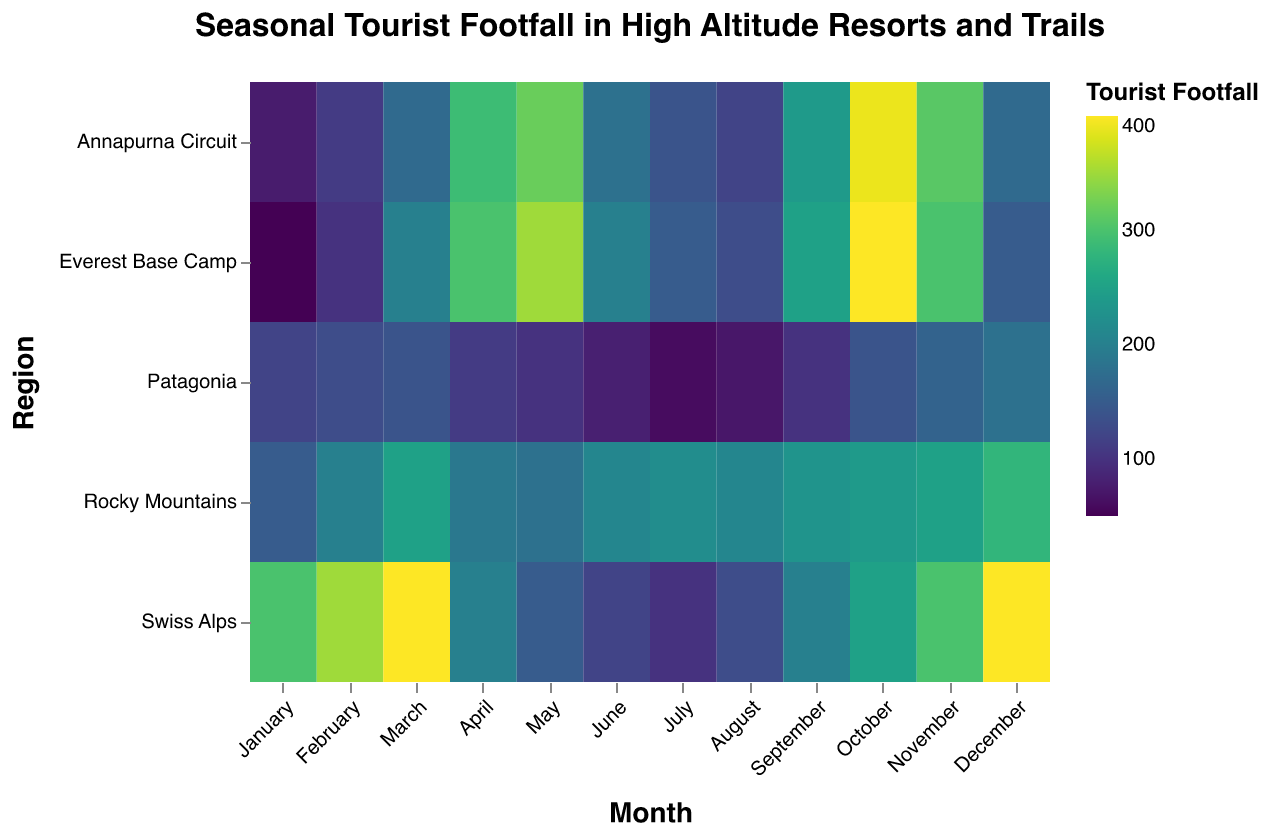Which region has the highest tourist footfall in October? Looking at the October column, the highest footfall is seen in Everest Base Camp with 400 tourists.
Answer: Everest Base Camp What is the average footfall in the Rocky Mountains over the entire year? The footfall values are 150, 200, 250, 190, 180, 210, 220, 210, 230, 240, 250, 280. Summing these gives a total of 2610. Dividing by 12 months gives an average of 217.5.
Answer: 217.5 Which month has the lowest footfall in Patagonia? The lowest value in the Patagonia row is in July with a footfall of 60.
Answer: July Compare the footfall in the Swiss Alps in March and December. Which month has more tourists, and by how many? The Swiss Alps have a footfall of 400 in both March and December. The difference is 400 - 400 = 0, so they are equal.
Answer: Equal, 0 Which region has the most consistent monthly footfall across the year? Consistency can be measured by the range of footfall values. The Rocky Mountains have the smallest range (280 - 150 = 130).
Answer: Rocky Mountains During which months do both Everest Base Camp and Annapurna Circuit see their peak tourist footfall? By looking at the rows for Everest Base Camp and Annapurna Circuit, both regions see their peak footfall in October.
Answer: October What is the combined footfall of the Everest Base Camp and Swiss Alps in May? The footfall in May for Everest Base Camp is 350 and for Swiss Alps is 150. Combined, this is 350 + 150 = 500.
Answer: 500 What trend do you observe in the footfall of the Patagonia region from January to December? Footfall in Patagonia starts at 120 in January, dips to 60 in July, and then rises again to 180 in December, indicating a U-shaped trend.
Answer: U-shaped trend Identify the region with the highest variability in tourist footfall per month. By observing the fluctuations, the Swiss Alps show high variability, especially with peaks of 400 in March/December and a low of 100 in July.
Answer: Swiss Alps 